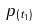<formula> <loc_0><loc_0><loc_500><loc_500>p _ { ( t _ { 1 } ) }</formula> 